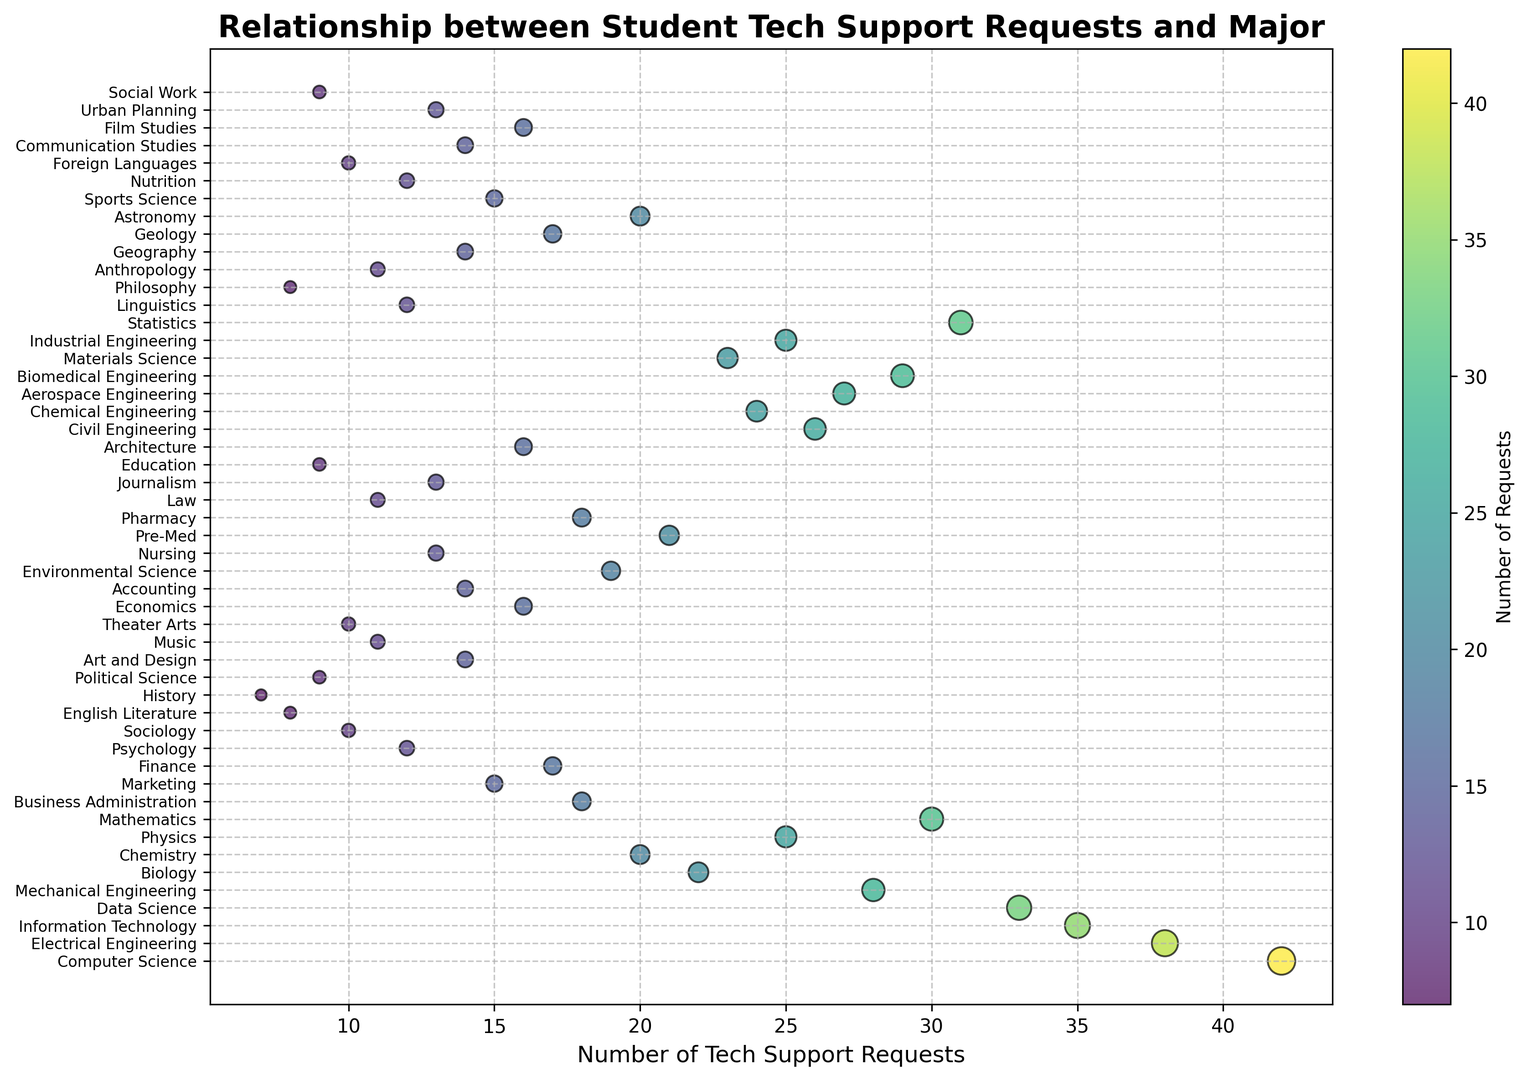Which major has the highest number of tech support requests? By examining the scatter plot, look for the dot located at the highest value on the x-axis (number of support requests).
Answer: Computer Science Which major has the second highest number of tech support requests? Identify the dot with the next highest x-axis value (number of requests) after the highest one.
Answer: Electrical Engineering What is the total number of tech support requests for all engineering majors combined? Add the number of support requests for all engineering majors (e.g., Computer Science, Electrical Engineering, Mechanical Engineering, etc.).
Answer: 262 Which major has fewer tech support requests: Psychology or Sociology? Compare the x-axis values (number of support requests) for Psychology and Sociology.
Answer: Sociology Identify the major with the median number of tech support requests. Order the number of support requests and find the middle value. With 49 data points, the median is the value at the 25th position in the sorted list.
Answer: Pre-Med What is the average number of tech support requests per major? Sum the total number of tech support requests and divide by the number of majors. Sum = 828, Number of majors = 49, so 828/49.
Answer: 16.9 Which majors have similar tech support request rates (clusters)? Look for groups of dots on the scatter plot that are close together in terms of x-axis values.
Answer: Chemistry, Astronomy, Materials Science Do students in humanities (e.g., English Literature, History) request more or fewer tech support on average compared to students in STEM (e.g., Biology, Chemistry)? Calculate the average number of requests for humanities and STEM majors separately, then compare the averages.
Answer: Fewer Which major has the largest dot size in the scatter plot? Examine the scatter plot, the size of the dots is proportional to the number of requests, so the largest dot will correspond to the major with the highest number of requests.
Answer: Computer Science 